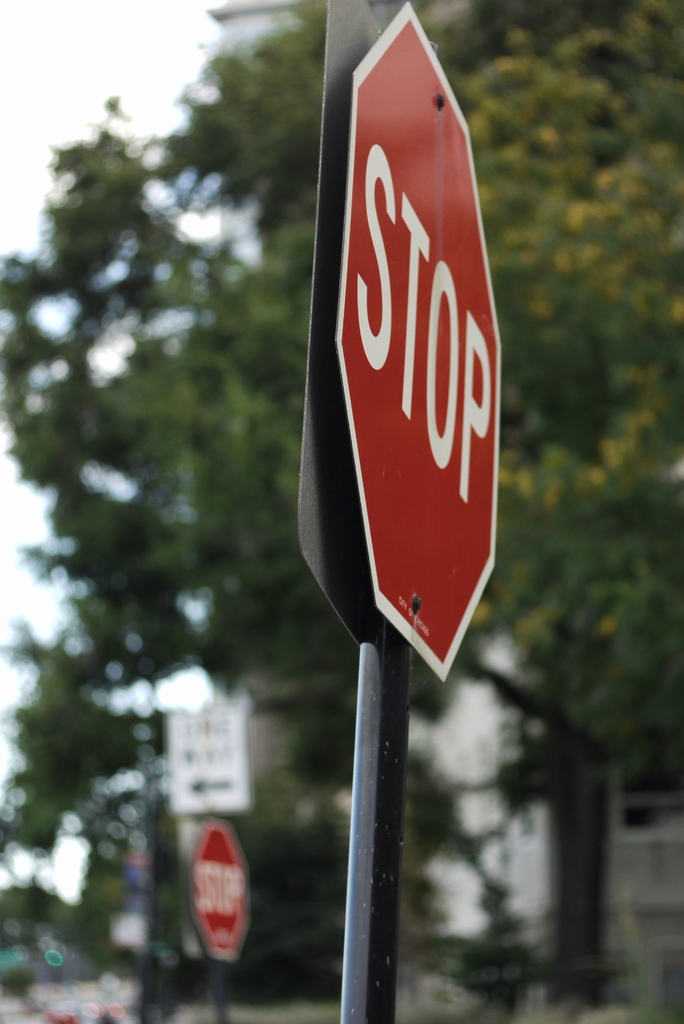Can you describe the main features of this image for me? The image captures a scene on a tree-lined street. Dominating the frame is a red stop sign mounted on a black pole. The word "STOP" is clearly visible on the sign. The sign is in sharp focus, drawing the viewer's attention to its message. In the blurred background, another stop sign can be glimpsed in the distance, along with a white building. The image conveys a sense of order and regulation, reminding viewers of the importance of observing traffic rules for safety. 